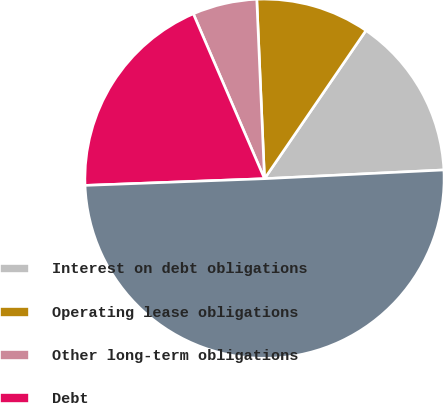<chart> <loc_0><loc_0><loc_500><loc_500><pie_chart><fcel>Interest on debt obligations<fcel>Operating lease obligations<fcel>Other long-term obligations<fcel>Debt<fcel>Total<nl><fcel>14.67%<fcel>10.24%<fcel>5.8%<fcel>19.11%<fcel>50.18%<nl></chart> 